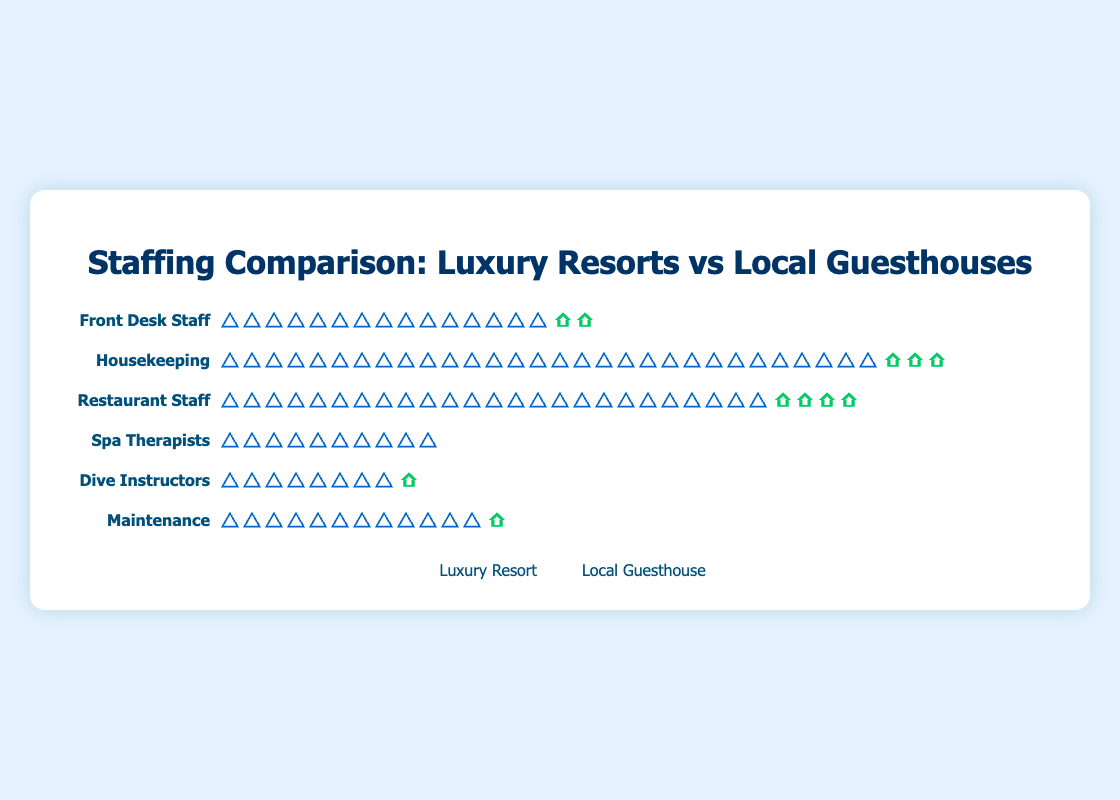What's the title of the figure? The title of the figure is displayed at the top center and it reads "Staffing Comparison: Luxury Resorts vs Local Guesthouses".
Answer: Staffing Comparison: Luxury Resorts vs Local Guesthouses Which role has the highest number of staff in both luxury resorts and local guesthouses combined? Count the staff for each role in both luxury resorts and local guesthouses, then sum them up: 
- Front Desk Staff: 15 (luxury) + 2 (local) = 17
- Housekeeping: 30 (luxury) + 3 (local) = 33
- Restaurant Staff: 25 (luxury) + 4 (local) = 29
- Spa Therapists: 10 (luxury) + 0 (local) = 10
- Dive Instructors: 8 (luxury) + 1 (local) = 9
- Maintenance: 12 (luxury) + 1 (local) = 13
The highest sum is Housekeeping with 33.
Answer: Housekeeping Which role has zero staff in local guesthouses? Based on the figure, Spa Therapists show only luxury resort icons and no local guesthouse icons. This indicates that there are zero Spa Therapists in local guesthouses.
Answer: Spa Therapists For which roles, the luxury resorts staff are more than 10 times the local guesthouses staff? Calculate the ratio of luxury resorts to local guesthouses for each role: 
- Front Desk Staff: 15 / 2 = 7.5
- Housekeeping: 30 / 3 = 10
- Restaurant Staff: 25 / 4 = 6.25
- Spa Therapists: 10 / 0 -> undefined but 10 is more than 10 times 0 because anything is more than zero.
- Dive Instructors: 8 / 1 = 8
- Maintenance: 12 / 1 = 12
The roles are Spa Therapists and Maintenance.
Answer: Spa Therapists, Maintenance How many total staff members are there in luxury resorts and local guesthouses for the role of Dive Instructors combined? The figure shows 8 luxury resort icons and 1 local guesthouse icon for Dive Instructors. Adding these values gives 8 + 1 = 9.
Answer: 9 Compare the number of Restaurant Staff in luxury resorts to the number of Housekeeping staff in local guesthouses. Which group is larger? The figure shows 25 icons for luxury resort Restaurant Staff and 3 icons for local guesthouse Housekeeping staff. Therefore, 25 (Restaurant Staff) is larger than 3 (Housekeeping staff).
Answer: Restaurant Staff in luxury resorts What is the combined total number of Front Desk Staff and Maintenance Staff in local guesthouses? Add the number of icons for Front Desk Staff and Maintenance Staff in local guesthouses: 2 (Front Desk Staff) + 1 (Maintenance Staff) = 3.
Answer: 3 